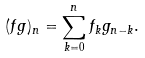<formula> <loc_0><loc_0><loc_500><loc_500>( f g ) _ { n } = \sum _ { k = 0 } ^ { n } f _ { k } g _ { n - k } .</formula> 